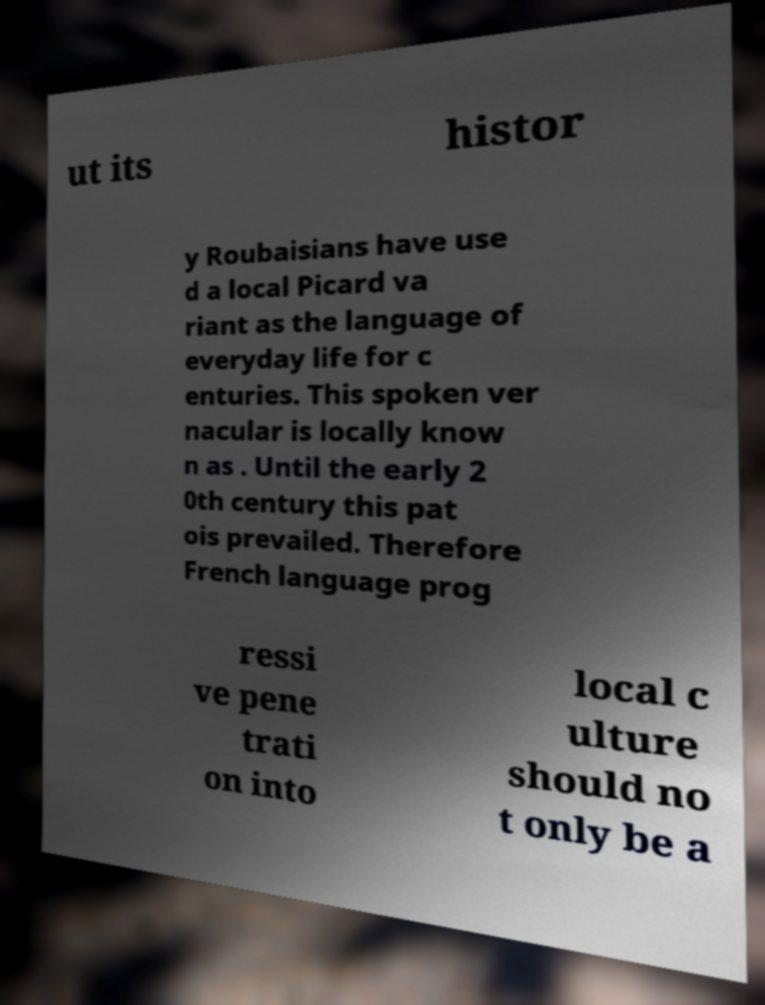Could you assist in decoding the text presented in this image and type it out clearly? ut its histor y Roubaisians have use d a local Picard va riant as the language of everyday life for c enturies. This spoken ver nacular is locally know n as . Until the early 2 0th century this pat ois prevailed. Therefore French language prog ressi ve pene trati on into local c ulture should no t only be a 